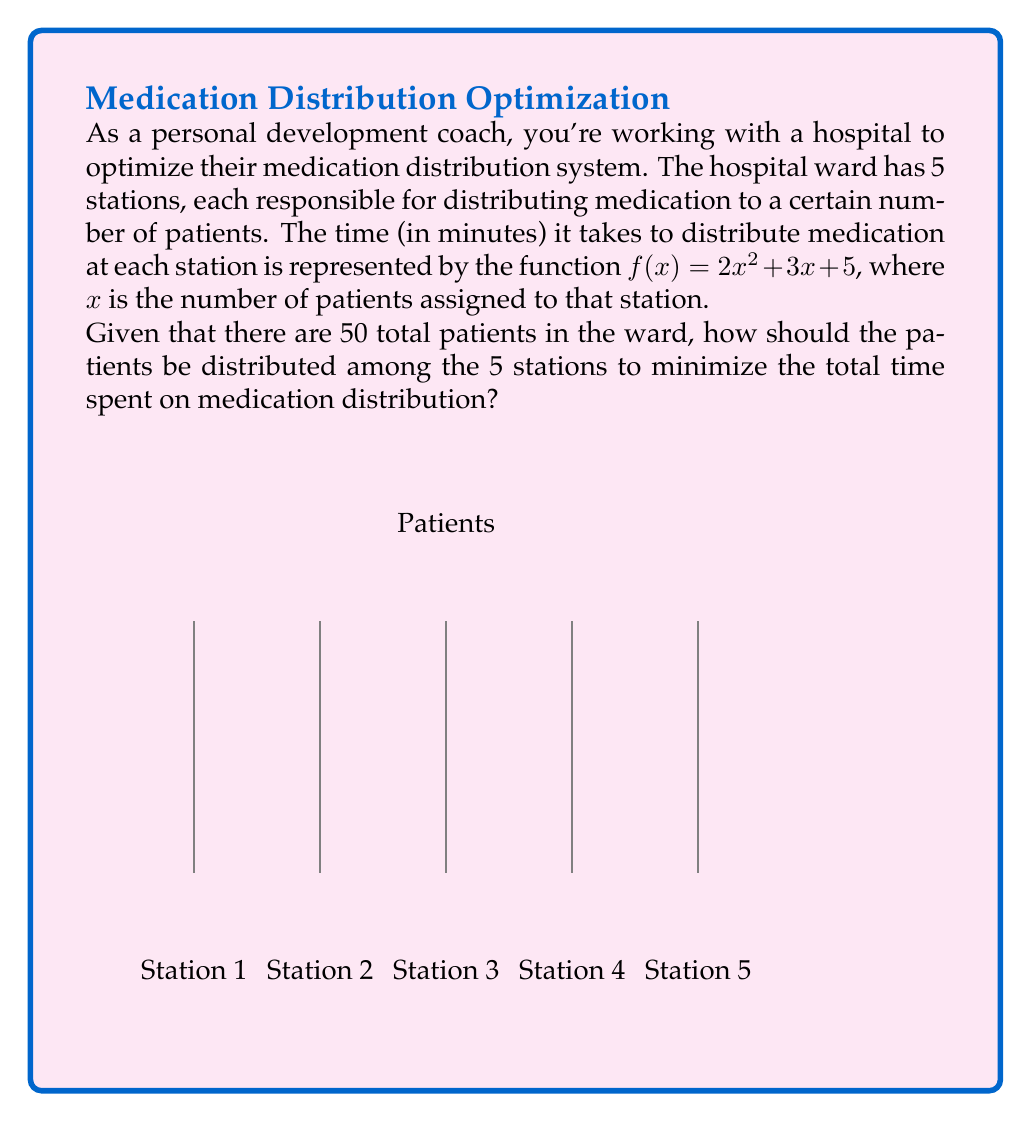What is the answer to this math problem? Let's approach this step-by-step:

1) We need to minimize the total time across all stations. Let $x_i$ be the number of patients at station $i$. Our objective function is:

   $$T = \sum_{i=1}^5 f(x_i) = \sum_{i=1}^5 (2x_i^2 + 3x_i + 5)$$

2) We have two constraints:
   a) The sum of patients across all stations must equal 50:
      $$\sum_{i=1}^5 x_i = 50$$
   b) The number of patients at each station must be non-negative:
      $$x_i \geq 0 \text{ for } i = 1,2,3,4,5$$

3) This is a constrained optimization problem. We can solve it using the method of Lagrange multipliers. However, due to the symmetry of the problem, we can deduce that the optimal solution will have an equal number of patients at each station.

4) If we distribute the patients equally, each station will have:
   $$x_1 = x_2 = x_3 = x_4 = x_5 = \frac{50}{5} = 10$$

5) To verify this is indeed the minimum, we can check that moving any patient from one station to another would increase the total time:

   Current time at each station: $f(10) = 2(10)^2 + 3(10) + 5 = 235$
   Total time: $5 * 235 = 1175$

   If we move one patient:
   New times: $f(9) + f(11) = (189 + 286) = 475$
   $475 > 2 * 235 = 470$

   This confirms that the equal distribution is optimal.
Answer: 10 patients per station 